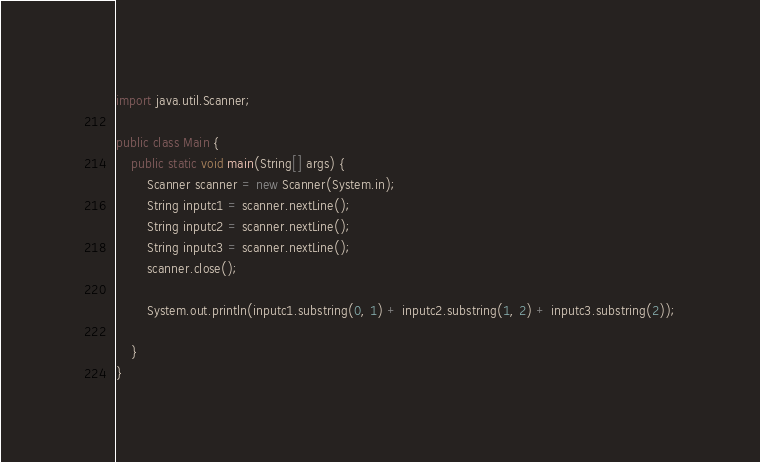Convert code to text. <code><loc_0><loc_0><loc_500><loc_500><_Java_>import java.util.Scanner;

public class Main {
	public static void main(String[] args) {
		Scanner scanner = new Scanner(System.in);
		String inputc1 = scanner.nextLine();
		String inputc2 = scanner.nextLine();
		String inputc3 = scanner.nextLine();
		scanner.close();

		System.out.println(inputc1.substring(0, 1) + inputc2.substring(1, 2) + inputc3.substring(2));

	}
}
</code> 